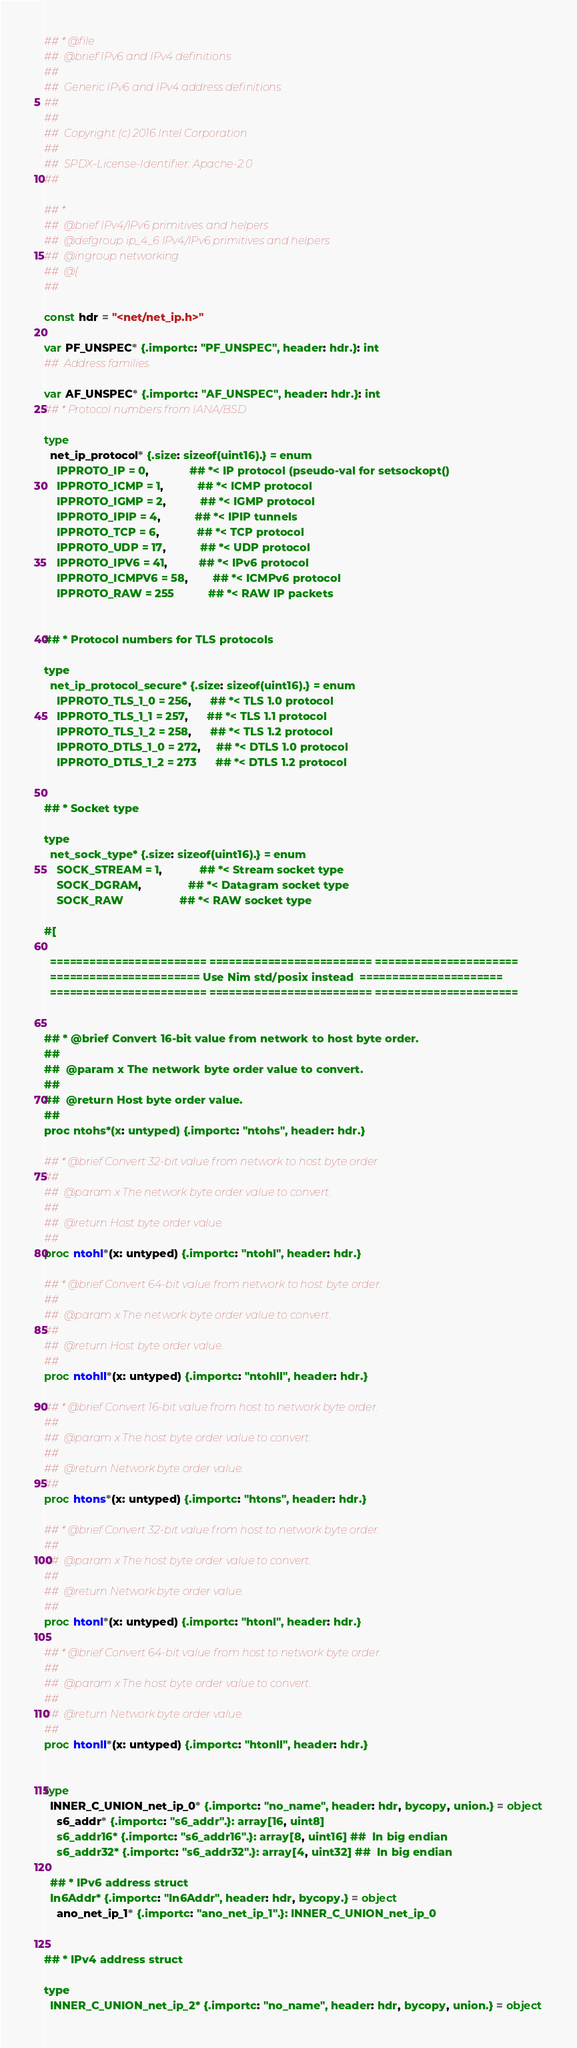<code> <loc_0><loc_0><loc_500><loc_500><_Nim_>## * @file
##  @brief IPv6 and IPv4 definitions
##
##  Generic IPv6 and IPv4 address definitions.
##
##
##  Copyright (c) 2016 Intel Corporation
##
##  SPDX-License-Identifier: Apache-2.0
##

## *
##  @brief IPv4/IPv6 primitives and helpers
##  @defgroup ip_4_6 IPv4/IPv6 primitives and helpers
##  @ingroup networking
##  @{
##

const hdr = "<net/net_ip.h>"

var PF_UNSPEC* {.importc: "PF_UNSPEC", header: hdr.}: int
##  Address families.

var AF_UNSPEC* {.importc: "AF_UNSPEC", header: hdr.}: int
## * Protocol numbers from IANA/BSD

type
  net_ip_protocol* {.size: sizeof(uint16).} = enum
    IPPROTO_IP = 0,             ## *< IP protocol (pseudo-val for setsockopt()
    IPPROTO_ICMP = 1,           ## *< ICMP protocol
    IPPROTO_IGMP = 2,           ## *< IGMP protocol
    IPPROTO_IPIP = 4,           ## *< IPIP tunnels
    IPPROTO_TCP = 6,            ## *< TCP protocol
    IPPROTO_UDP = 17,           ## *< UDP protocol
    IPPROTO_IPV6 = 41,          ## *< IPv6 protocol
    IPPROTO_ICMPV6 = 58,        ## *< ICMPv6 protocol
    IPPROTO_RAW = 255           ## *< RAW IP packets


## * Protocol numbers for TLS protocols

type
  net_ip_protocol_secure* {.size: sizeof(uint16).} = enum
    IPPROTO_TLS_1_0 = 256,      ## *< TLS 1.0 protocol
    IPPROTO_TLS_1_1 = 257,      ## *< TLS 1.1 protocol
    IPPROTO_TLS_1_2 = 258,      ## *< TLS 1.2 protocol
    IPPROTO_DTLS_1_0 = 272,     ## *< DTLS 1.0 protocol
    IPPROTO_DTLS_1_2 = 273      ## *< DTLS 1.2 protocol


## * Socket type

type
  net_sock_type* {.size: sizeof(uint16).} = enum
    SOCK_STREAM = 1,            ## *< Stream socket type
    SOCK_DGRAM,               ## *< Datagram socket type
    SOCK_RAW                  ## *< RAW socket type

#[

  ======================== ========================= ====================== 
  ======================= Use Nim std/posix instead  ====================== 
  ======================== ========================= ====================== 


## * @brief Convert 16-bit value from network to host byte order.
##
##  @param x The network byte order value to convert.
##
##  @return Host byte order value.
##
proc ntohs*(x: untyped) {.importc: "ntohs", header: hdr.}

## * @brief Convert 32-bit value from network to host byte order.
##
##  @param x The network byte order value to convert.
##
##  @return Host byte order value.
##
proc ntohl*(x: untyped) {.importc: "ntohl", header: hdr.}

## * @brief Convert 64-bit value from network to host byte order.
##
##  @param x The network byte order value to convert.
##
##  @return Host byte order value.
##
proc ntohll*(x: untyped) {.importc: "ntohll", header: hdr.}

## * @brief Convert 16-bit value from host to network byte order.
##
##  @param x The host byte order value to convert.
##
##  @return Network byte order value.
##
proc htons*(x: untyped) {.importc: "htons", header: hdr.}

## * @brief Convert 32-bit value from host to network byte order.
##
##  @param x The host byte order value to convert.
##
##  @return Network byte order value.
##
proc htonl*(x: untyped) {.importc: "htonl", header: hdr.}

## * @brief Convert 64-bit value from host to network byte order.
##
##  @param x The host byte order value to convert.
##
##  @return Network byte order value.
##
proc htonll*(x: untyped) {.importc: "htonll", header: hdr.}


type
  INNER_C_UNION_net_ip_0* {.importc: "no_name", header: hdr, bycopy, union.} = object
    s6_addr* {.importc: "s6_addr".}: array[16, uint8]
    s6_addr16* {.importc: "s6_addr16".}: array[8, uint16] ##  In big endian
    s6_addr32* {.importc: "s6_addr32".}: array[4, uint32] ##  In big endian

  ## * IPv6 address struct
  In6Addr* {.importc: "In6Addr", header: hdr, bycopy.} = object
    ano_net_ip_1* {.importc: "ano_net_ip_1".}: INNER_C_UNION_net_ip_0


## * IPv4 address struct

type
  INNER_C_UNION_net_ip_2* {.importc: "no_name", header: hdr, bycopy, union.} = object</code> 